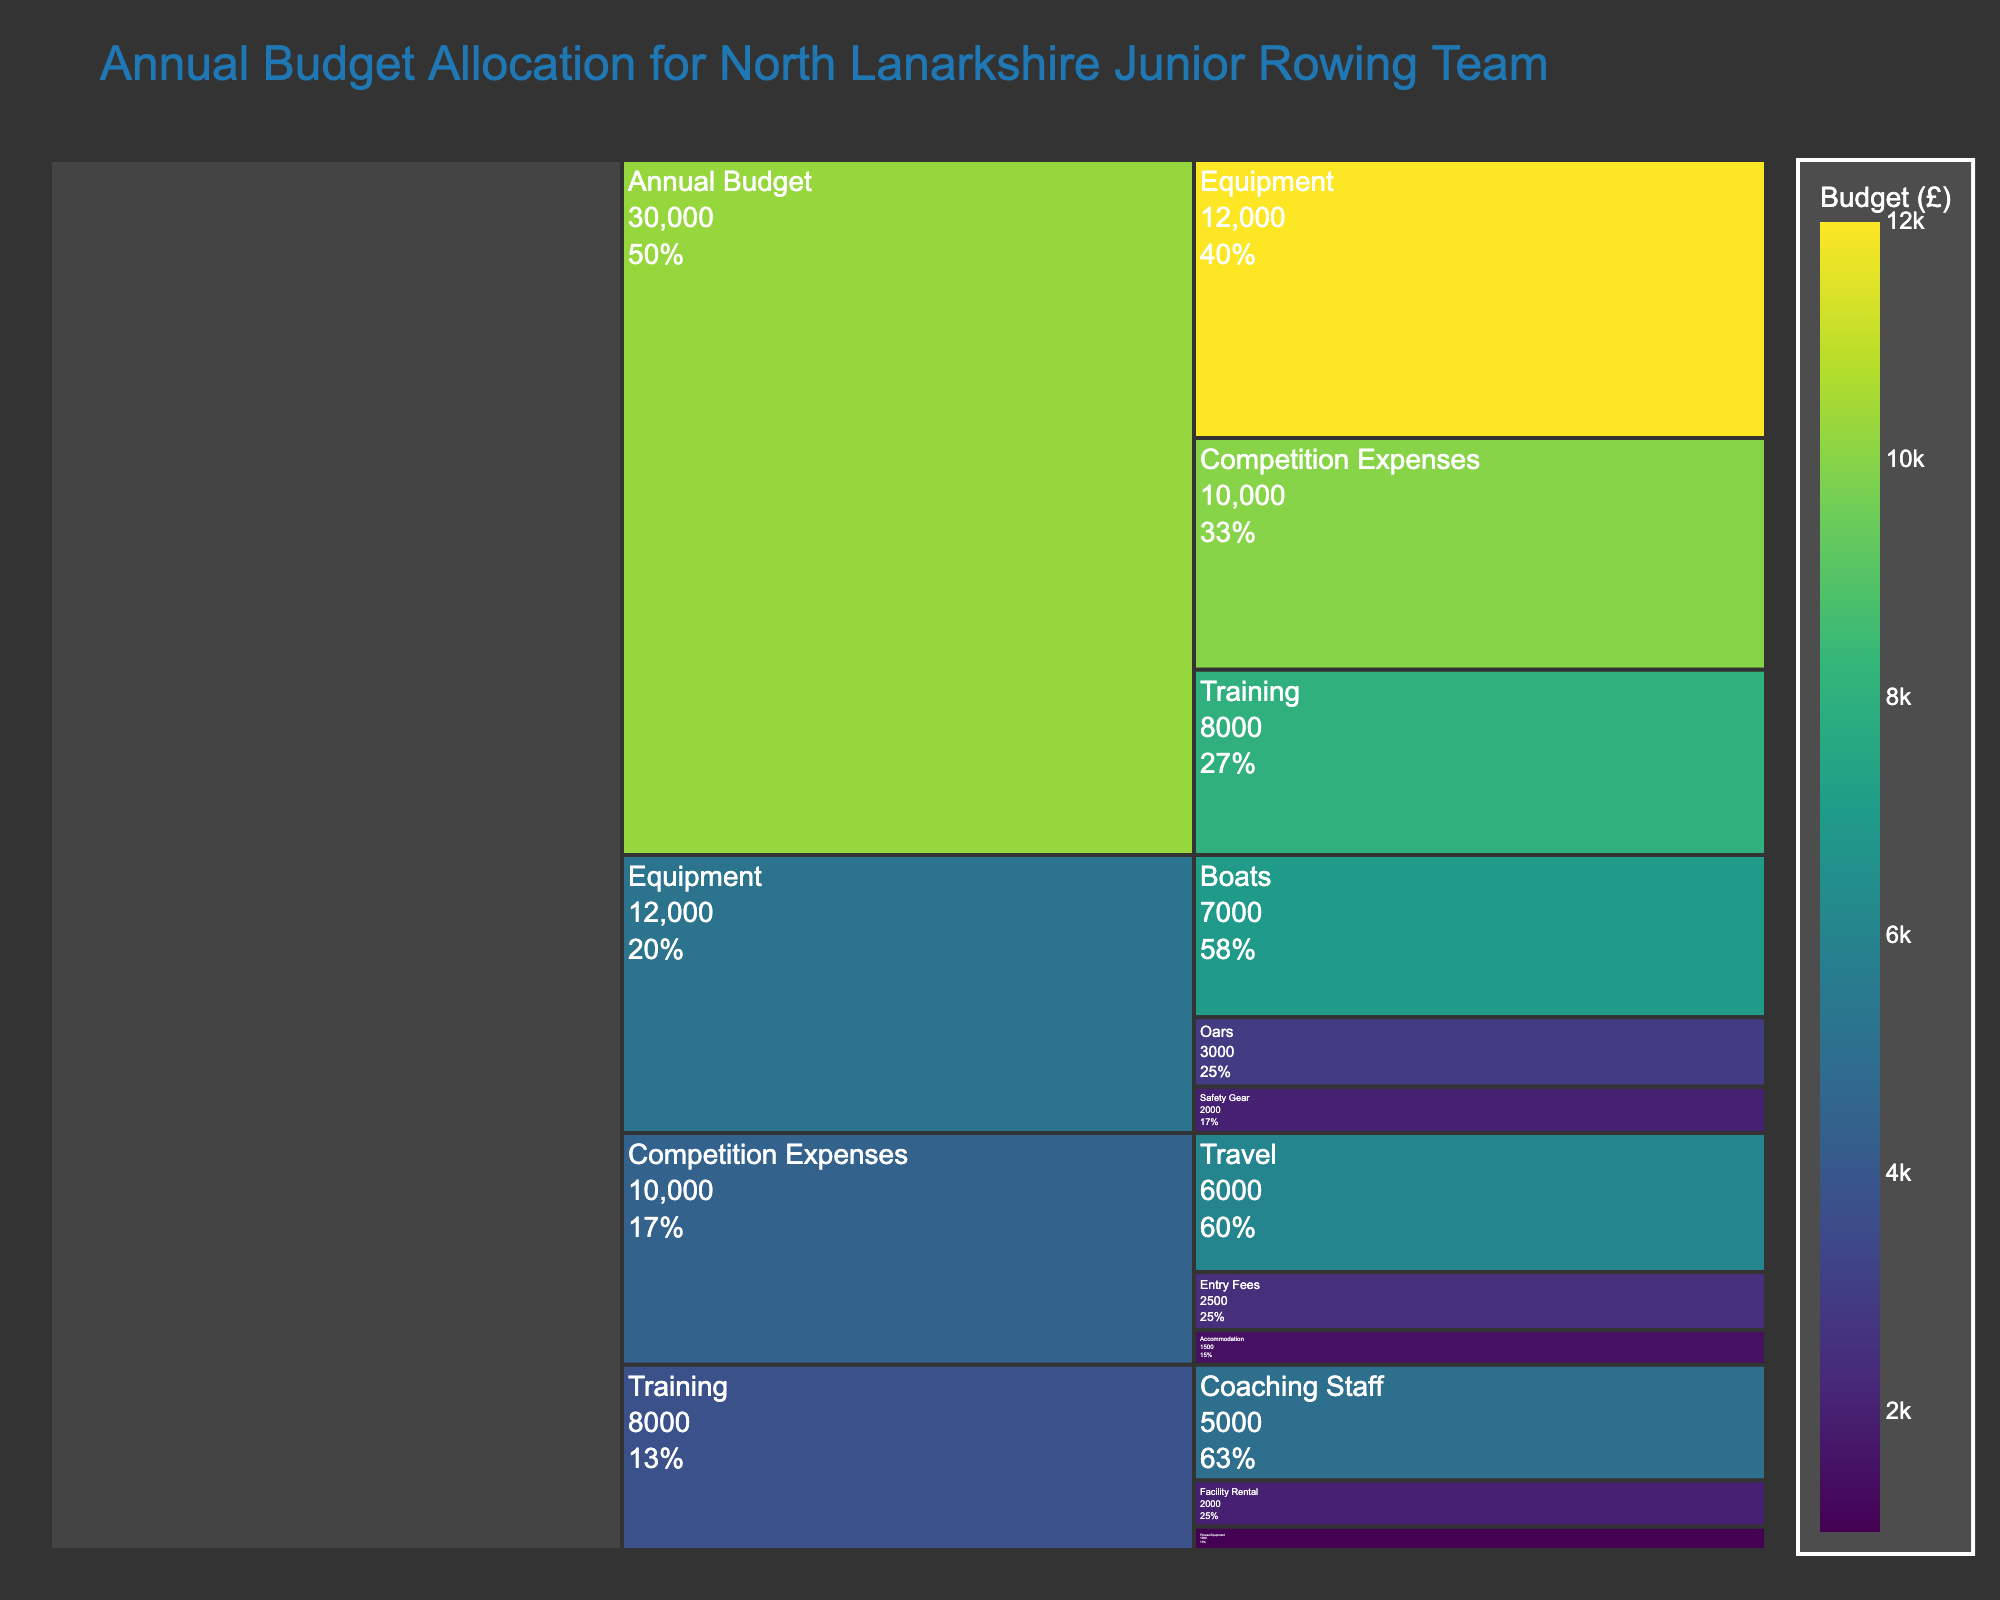what is the total annual budget for the rowing team? The total annual budget is the value at the top level of the icicle chart. It sums up all the expenditures in Equipment, Training, and Competition Expenses, which is shown as 30,000.
Answer: 30,000 how much is spent on training? The Training section of the icicle chart shows a direct value of 8,000.
Answer: 8,000 what percentage of the Equipment budget is allocated to boats? The Equipment section total is 12,000, and within it, the allocation for Boats is 7,000. Therefore, the percentage is (7000/12000) * 100 = 58.33%.
Answer: 58.33% compare the budget for Entry Fees and Travel in Competition Expenses The budget allocated for Entry Fees is shown as 2,500 and for Travel, it is 6,000. Therefore, Travel has a significantly higher budget compared to Entry Fees.
Answer: Travel > Entry Fees is the budget for Fitness Equipment higher or lower than the budget for Accommodation? The Fitness Equipment budget is 1,000 and the Accommodation budget is 1,500. Therefore, the budget for Fitness Equipment is lower.
Answer: Lower sum the budgets for Coaching Staff and Facility Rental The Coaching Staff budget is 5,000 and the Facility Rental budget is 2,000. Adding these up gives 5,000 + 2,000 = 7,000.
Answer: 7,000 what is the largest single expense item shown in the chart? The largest single expense item is in the Equipment section for Boats, which is 7,000.
Answer: Boats which category has the highest overall budget allocation? The Equipment category is the highest with a total budget of 12,000 as compared to Training and Competition Expenses.
Answer: Equipment how much more is spent on Competition Expenses compared to the Training budget? The budget for Competition Expenses is 10,000 and for Training, it is 8,000. Therefore, the difference is 10,000 - 8,000 = 2,000.
Answer: 2,000 what are the subcategory allocations within the Training budget? Within the Training budget, the Coaching Staff is allocated 5,000, Facility Rental is 2,000, and Fitness Equipment is 1,000.
Answer: Coaching Staff: 5,000, Facility Rental: 2,000, Fitness Equipment: 1,000 